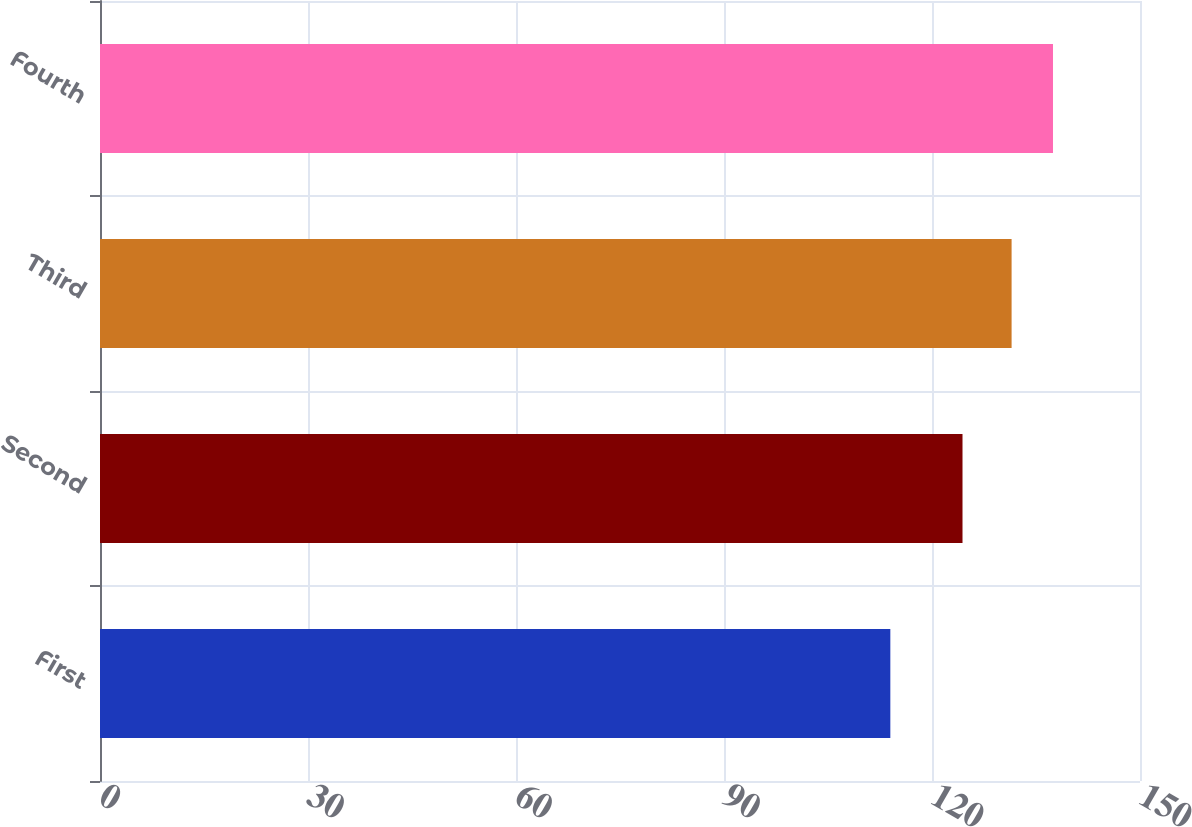<chart> <loc_0><loc_0><loc_500><loc_500><bar_chart><fcel>First<fcel>Second<fcel>Third<fcel>Fourth<nl><fcel>113.99<fcel>124.4<fcel>131.48<fcel>137.45<nl></chart> 